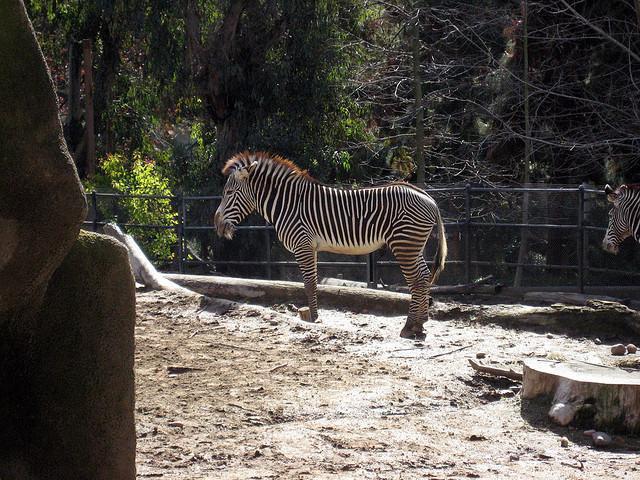How many different kinds of animals are in the picture?
Give a very brief answer. 1. How many dogs are in this picture?
Give a very brief answer. 0. 